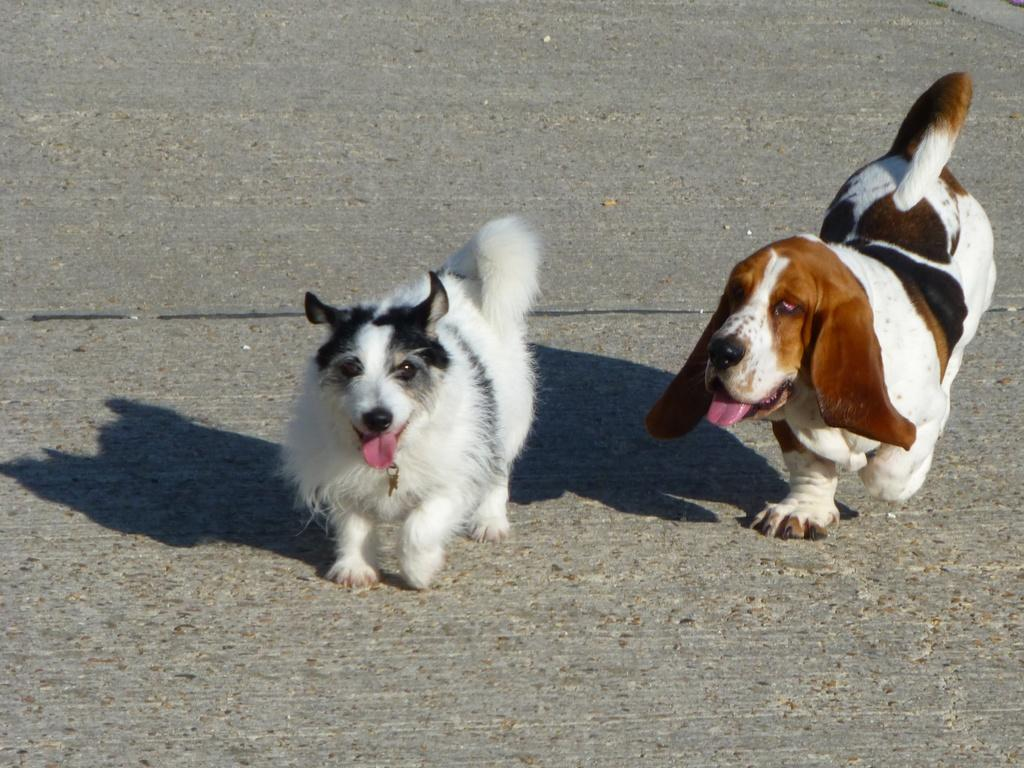How many dogs are present in the image? There are two dogs in the image. Where are the dogs located? The dogs are on the road. What type of sugar can be seen in the image? There is no sugar present in the image; it features two dogs on the road. Is there a cave visible in the image? There is no cave present in the image; it features two dogs on the road. 